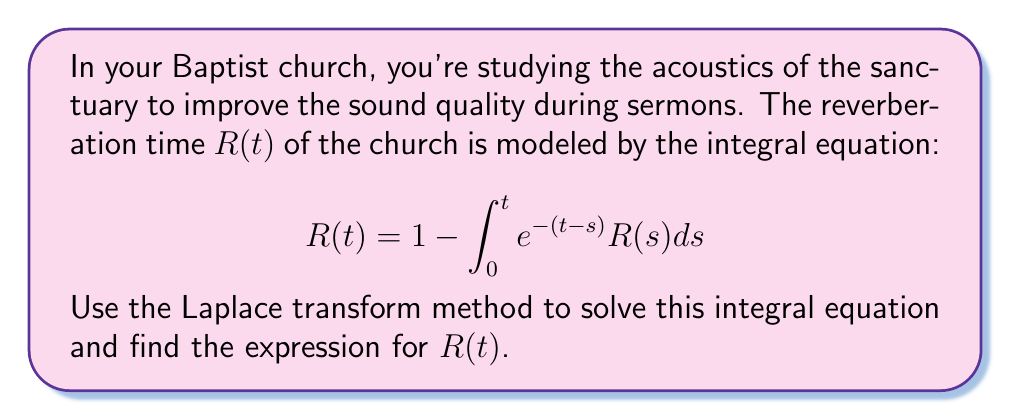Can you solve this math problem? Let's solve this step-by-step using Laplace transforms:

1) Let $\mathcal{L}\{R(t)\} = r(s)$. Take the Laplace transform of both sides:

   $$\mathcal{L}\{R(t)\} = \mathcal{L}\{1\} - \mathcal{L}\{\int_0^t e^{-(t-s)}R(s)ds\}$$

2) Using Laplace transform properties:

   $$r(s) = \frac{1}{s} - \mathcal{L}\{e^{-t}\} \cdot r(s)$$

3) We know that $\mathcal{L}\{e^{-t}\} = \frac{1}{s+1}$, so:

   $$r(s) = \frac{1}{s} - \frac{1}{s+1} \cdot r(s)$$

4) Solve for $r(s)$:

   $$r(s) + \frac{1}{s+1} \cdot r(s) = \frac{1}{s}$$
   $$r(s) \cdot (1 + \frac{1}{s+1}) = \frac{1}{s}$$
   $$r(s) \cdot (\frac{s+2}{s+1}) = \frac{1}{s}$$

   $$r(s) = \frac{s+1}{s(s+2)}$$

5) Decompose into partial fractions:

   $$r(s) = \frac{A}{s} + \frac{B}{s+2}$$

   $$A(s+2) + Bs = s+1$$

   When $s=0$: $2A = 1$, so $A = \frac{1}{2}$
   When $s=-2$: $-2B = -1$, so $B = \frac{1}{2}$

   $$r(s) = \frac{1/2}{s} + \frac{1/2}{s+2}$$

6) Take the inverse Laplace transform:

   $$R(t) = \mathcal{L}^{-1}\{r(s)\} = \frac{1}{2} \cdot 1 + \frac{1}{2} \cdot e^{-2t}$$

Therefore, the solution is:

$$R(t) = \frac{1}{2} + \frac{1}{2}e^{-2t}$$
Answer: $R(t) = \frac{1}{2} + \frac{1}{2}e^{-2t}$ 